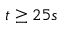Convert formula to latex. <formula><loc_0><loc_0><loc_500><loc_500>t \geq 2 5 s</formula> 